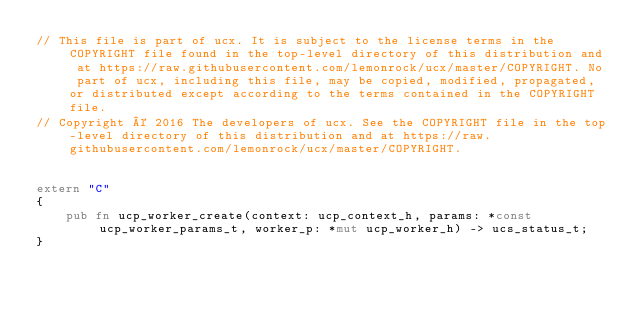<code> <loc_0><loc_0><loc_500><loc_500><_Rust_>// This file is part of ucx. It is subject to the license terms in the COPYRIGHT file found in the top-level directory of this distribution and at https://raw.githubusercontent.com/lemonrock/ucx/master/COPYRIGHT. No part of ucx, including this file, may be copied, modified, propagated, or distributed except according to the terms contained in the COPYRIGHT file.
// Copyright © 2016 The developers of ucx. See the COPYRIGHT file in the top-level directory of this distribution and at https://raw.githubusercontent.com/lemonrock/ucx/master/COPYRIGHT.


extern "C"
{
	pub fn ucp_worker_create(context: ucp_context_h, params: *const ucp_worker_params_t, worker_p: *mut ucp_worker_h) -> ucs_status_t;
}
</code> 